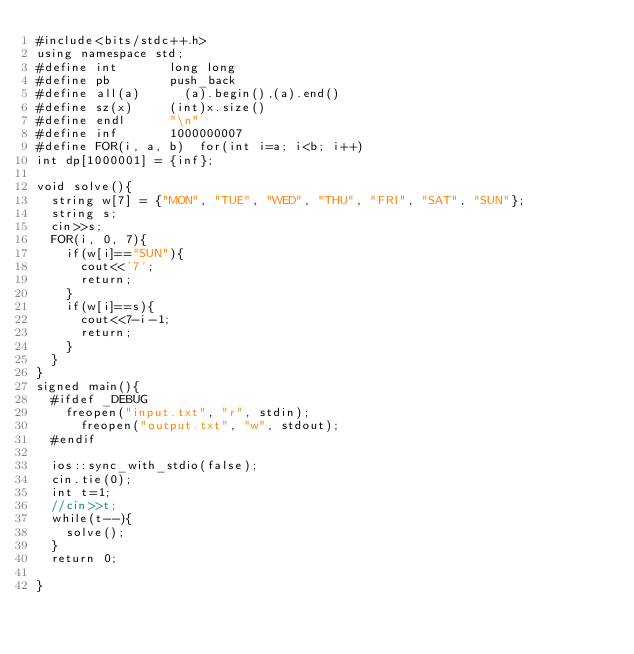Convert code to text. <code><loc_0><loc_0><loc_500><loc_500><_C++_>#include<bits/stdc++.h>
using namespace std;
#define int 		  long long
#define	pb 			  push_back
#define all(a)		  (a).begin(),(a).end()
#define sz(x)		  (int)x.size()
#define endl	 	  "\n"
#define inf 		  1000000007
#define FOR(i, a, b)  for(int i=a; i<b; i++)
int dp[1000001] = {inf};

void solve(){
	string w[7] = {"MON", "TUE", "WED", "THU", "FRI", "SAT", "SUN"};
	string s;
	cin>>s;
	FOR(i, 0, 7){
		if(w[i]=="SUN"){
			cout<<'7';
			return;
		}
		if(w[i]==s){
			cout<<7-i-1;
			return;
		}
	}
}
signed main(){
	#ifdef _DEBUG
		freopen("input.txt", "r", stdin);
    	freopen("output.txt", "w", stdout);
	#endif
	
	ios::sync_with_stdio(false);
	cin.tie(0);
	int t=1;
	//cin>>t;
	while(t--){
		solve();
	}
	return 0;
 
}</code> 